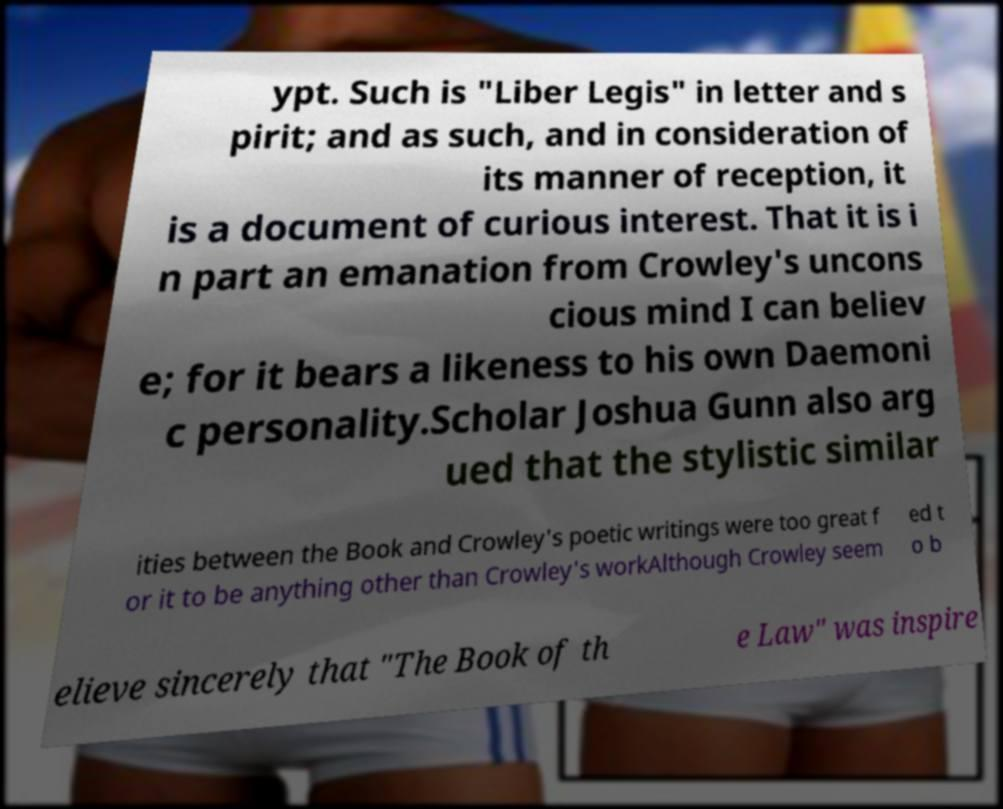Please identify and transcribe the text found in this image. ypt. Such is "Liber Legis" in letter and s pirit; and as such, and in consideration of its manner of reception, it is a document of curious interest. That it is i n part an emanation from Crowley's uncons cious mind I can believ e; for it bears a likeness to his own Daemoni c personality.Scholar Joshua Gunn also arg ued that the stylistic similar ities between the Book and Crowley's poetic writings were too great f or it to be anything other than Crowley's workAlthough Crowley seem ed t o b elieve sincerely that "The Book of th e Law" was inspire 